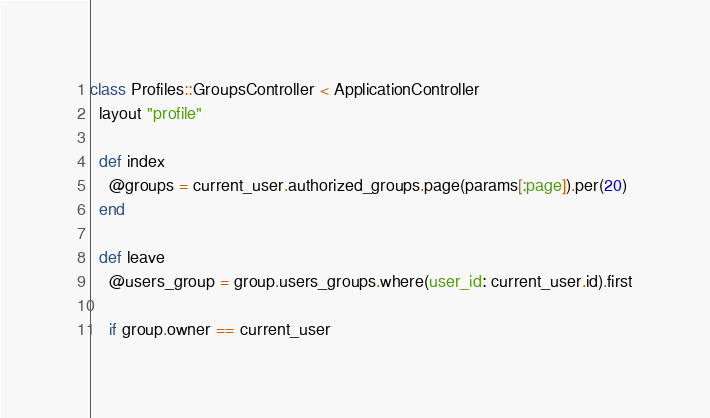<code> <loc_0><loc_0><loc_500><loc_500><_Ruby_>class Profiles::GroupsController < ApplicationController
  layout "profile"

  def index
    @groups = current_user.authorized_groups.page(params[:page]).per(20)
  end

  def leave
    @users_group = group.users_groups.where(user_id: current_user.id).first

    if group.owner == current_user</code> 